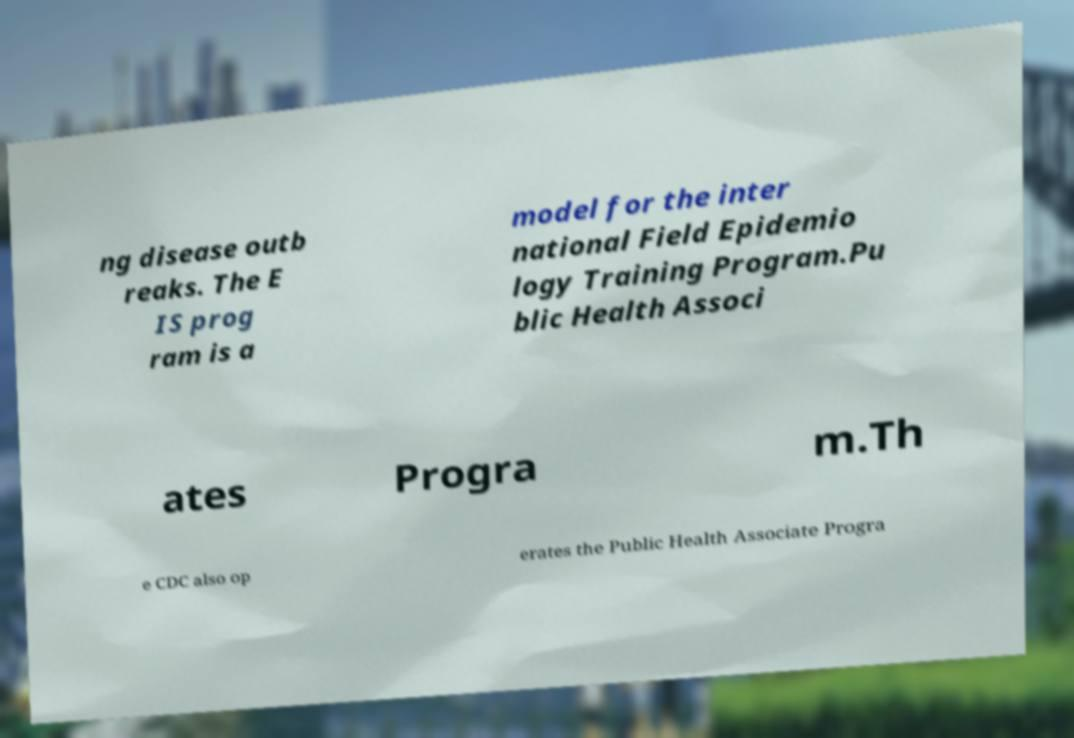Please read and relay the text visible in this image. What does it say? ng disease outb reaks. The E IS prog ram is a model for the inter national Field Epidemio logy Training Program.Pu blic Health Associ ates Progra m.Th e CDC also op erates the Public Health Associate Progra 